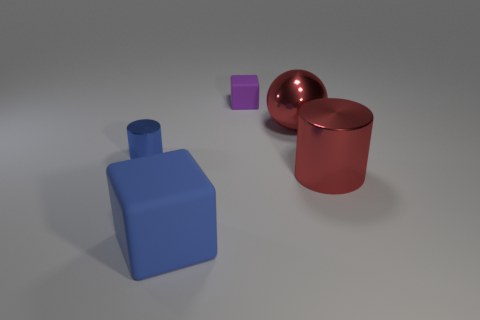Add 5 matte cubes. How many objects exist? 10 Subtract all red cylinders. How many cylinders are left? 1 Subtract all cylinders. How many objects are left? 3 Subtract 2 cylinders. How many cylinders are left? 0 Subtract all cyan cylinders. How many yellow balls are left? 0 Subtract all small gray metallic cylinders. Subtract all big rubber blocks. How many objects are left? 4 Add 5 cubes. How many cubes are left? 7 Add 1 purple rubber things. How many purple rubber things exist? 2 Subtract 0 cyan cylinders. How many objects are left? 5 Subtract all brown balls. Subtract all yellow blocks. How many balls are left? 1 